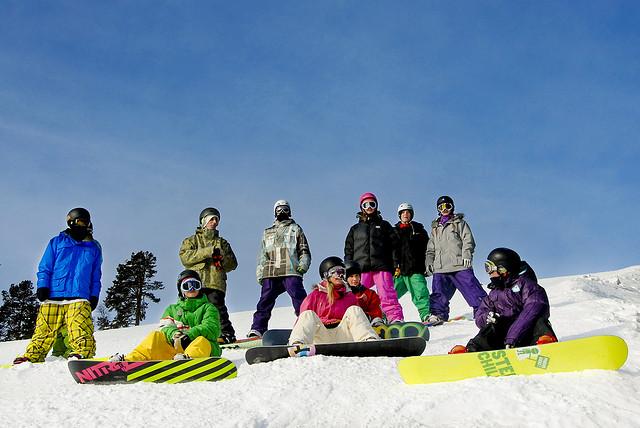What color jacket is the person wearing the pink pants have on?
Concise answer only. Black. What color is the snow?
Quick response, please. White. Will they be skiing?
Answer briefly. No. What colors are the skiers wearing?
Concise answer only. Bright. 